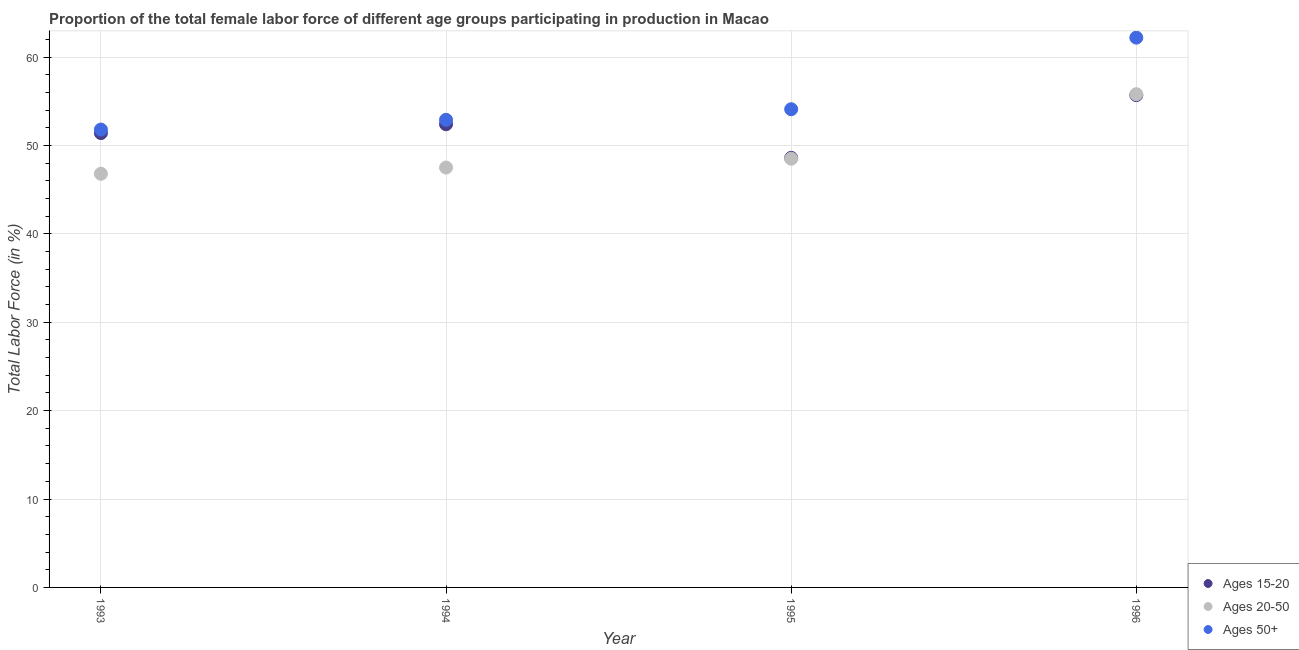How many different coloured dotlines are there?
Offer a very short reply. 3. Is the number of dotlines equal to the number of legend labels?
Offer a terse response. Yes. What is the percentage of female labor force above age 50 in 1993?
Provide a short and direct response. 51.8. Across all years, what is the maximum percentage of female labor force within the age group 20-50?
Keep it short and to the point. 55.8. Across all years, what is the minimum percentage of female labor force within the age group 20-50?
Make the answer very short. 46.8. In which year was the percentage of female labor force above age 50 minimum?
Offer a very short reply. 1993. What is the total percentage of female labor force above age 50 in the graph?
Ensure brevity in your answer.  221. What is the difference between the percentage of female labor force within the age group 15-20 in 1995 and that in 1996?
Make the answer very short. -7.1. What is the difference between the percentage of female labor force within the age group 20-50 in 1994 and the percentage of female labor force within the age group 15-20 in 1996?
Your response must be concise. -8.2. What is the average percentage of female labor force within the age group 20-50 per year?
Give a very brief answer. 49.65. In the year 1993, what is the difference between the percentage of female labor force above age 50 and percentage of female labor force within the age group 15-20?
Make the answer very short. 0.4. What is the ratio of the percentage of female labor force above age 50 in 1993 to that in 1996?
Ensure brevity in your answer.  0.83. Is the difference between the percentage of female labor force within the age group 15-20 in 1994 and 1996 greater than the difference between the percentage of female labor force within the age group 20-50 in 1994 and 1996?
Keep it short and to the point. Yes. What is the difference between the highest and the second highest percentage of female labor force within the age group 20-50?
Offer a very short reply. 7.3. What is the difference between the highest and the lowest percentage of female labor force above age 50?
Offer a terse response. 10.4. In how many years, is the percentage of female labor force within the age group 15-20 greater than the average percentage of female labor force within the age group 15-20 taken over all years?
Provide a succinct answer. 2. Is the sum of the percentage of female labor force within the age group 20-50 in 1994 and 1996 greater than the maximum percentage of female labor force above age 50 across all years?
Your answer should be very brief. Yes. Is the percentage of female labor force above age 50 strictly greater than the percentage of female labor force within the age group 15-20 over the years?
Provide a short and direct response. Yes. How many years are there in the graph?
Your answer should be compact. 4. Where does the legend appear in the graph?
Your response must be concise. Bottom right. What is the title of the graph?
Your answer should be compact. Proportion of the total female labor force of different age groups participating in production in Macao. What is the label or title of the Y-axis?
Provide a succinct answer. Total Labor Force (in %). What is the Total Labor Force (in %) in Ages 15-20 in 1993?
Your answer should be very brief. 51.4. What is the Total Labor Force (in %) of Ages 20-50 in 1993?
Offer a terse response. 46.8. What is the Total Labor Force (in %) in Ages 50+ in 1993?
Provide a succinct answer. 51.8. What is the Total Labor Force (in %) of Ages 15-20 in 1994?
Ensure brevity in your answer.  52.4. What is the Total Labor Force (in %) in Ages 20-50 in 1994?
Make the answer very short. 47.5. What is the Total Labor Force (in %) in Ages 50+ in 1994?
Your answer should be compact. 52.9. What is the Total Labor Force (in %) in Ages 15-20 in 1995?
Offer a terse response. 48.6. What is the Total Labor Force (in %) in Ages 20-50 in 1995?
Your answer should be compact. 48.5. What is the Total Labor Force (in %) in Ages 50+ in 1995?
Provide a succinct answer. 54.1. What is the Total Labor Force (in %) of Ages 15-20 in 1996?
Your response must be concise. 55.7. What is the Total Labor Force (in %) of Ages 20-50 in 1996?
Ensure brevity in your answer.  55.8. What is the Total Labor Force (in %) in Ages 50+ in 1996?
Offer a terse response. 62.2. Across all years, what is the maximum Total Labor Force (in %) in Ages 15-20?
Your response must be concise. 55.7. Across all years, what is the maximum Total Labor Force (in %) in Ages 20-50?
Your answer should be compact. 55.8. Across all years, what is the maximum Total Labor Force (in %) of Ages 50+?
Make the answer very short. 62.2. Across all years, what is the minimum Total Labor Force (in %) in Ages 15-20?
Make the answer very short. 48.6. Across all years, what is the minimum Total Labor Force (in %) in Ages 20-50?
Your answer should be very brief. 46.8. Across all years, what is the minimum Total Labor Force (in %) of Ages 50+?
Your response must be concise. 51.8. What is the total Total Labor Force (in %) of Ages 15-20 in the graph?
Make the answer very short. 208.1. What is the total Total Labor Force (in %) in Ages 20-50 in the graph?
Keep it short and to the point. 198.6. What is the total Total Labor Force (in %) in Ages 50+ in the graph?
Your response must be concise. 221. What is the difference between the Total Labor Force (in %) of Ages 50+ in 1993 and that in 1995?
Provide a short and direct response. -2.3. What is the difference between the Total Labor Force (in %) in Ages 15-20 in 1993 and that in 1996?
Give a very brief answer. -4.3. What is the difference between the Total Labor Force (in %) of Ages 20-50 in 1993 and that in 1996?
Provide a short and direct response. -9. What is the difference between the Total Labor Force (in %) in Ages 50+ in 1993 and that in 1996?
Offer a very short reply. -10.4. What is the difference between the Total Labor Force (in %) of Ages 20-50 in 1994 and that in 1995?
Provide a short and direct response. -1. What is the difference between the Total Labor Force (in %) in Ages 50+ in 1994 and that in 1995?
Give a very brief answer. -1.2. What is the difference between the Total Labor Force (in %) of Ages 15-20 in 1994 and that in 1996?
Make the answer very short. -3.3. What is the difference between the Total Labor Force (in %) of Ages 20-50 in 1995 and that in 1996?
Offer a very short reply. -7.3. What is the difference between the Total Labor Force (in %) in Ages 20-50 in 1993 and the Total Labor Force (in %) in Ages 50+ in 1994?
Make the answer very short. -6.1. What is the difference between the Total Labor Force (in %) of Ages 15-20 in 1993 and the Total Labor Force (in %) of Ages 50+ in 1995?
Provide a short and direct response. -2.7. What is the difference between the Total Labor Force (in %) of Ages 15-20 in 1993 and the Total Labor Force (in %) of Ages 20-50 in 1996?
Provide a short and direct response. -4.4. What is the difference between the Total Labor Force (in %) of Ages 15-20 in 1993 and the Total Labor Force (in %) of Ages 50+ in 1996?
Make the answer very short. -10.8. What is the difference between the Total Labor Force (in %) of Ages 20-50 in 1993 and the Total Labor Force (in %) of Ages 50+ in 1996?
Your answer should be very brief. -15.4. What is the difference between the Total Labor Force (in %) in Ages 15-20 in 1994 and the Total Labor Force (in %) in Ages 20-50 in 1996?
Offer a terse response. -3.4. What is the difference between the Total Labor Force (in %) of Ages 15-20 in 1994 and the Total Labor Force (in %) of Ages 50+ in 1996?
Your response must be concise. -9.8. What is the difference between the Total Labor Force (in %) of Ages 20-50 in 1994 and the Total Labor Force (in %) of Ages 50+ in 1996?
Make the answer very short. -14.7. What is the difference between the Total Labor Force (in %) of Ages 15-20 in 1995 and the Total Labor Force (in %) of Ages 20-50 in 1996?
Your response must be concise. -7.2. What is the difference between the Total Labor Force (in %) of Ages 15-20 in 1995 and the Total Labor Force (in %) of Ages 50+ in 1996?
Make the answer very short. -13.6. What is the difference between the Total Labor Force (in %) of Ages 20-50 in 1995 and the Total Labor Force (in %) of Ages 50+ in 1996?
Make the answer very short. -13.7. What is the average Total Labor Force (in %) of Ages 15-20 per year?
Offer a very short reply. 52.02. What is the average Total Labor Force (in %) in Ages 20-50 per year?
Offer a very short reply. 49.65. What is the average Total Labor Force (in %) of Ages 50+ per year?
Your answer should be compact. 55.25. In the year 1993, what is the difference between the Total Labor Force (in %) in Ages 15-20 and Total Labor Force (in %) in Ages 50+?
Your answer should be compact. -0.4. In the year 1993, what is the difference between the Total Labor Force (in %) of Ages 20-50 and Total Labor Force (in %) of Ages 50+?
Make the answer very short. -5. In the year 1994, what is the difference between the Total Labor Force (in %) in Ages 15-20 and Total Labor Force (in %) in Ages 20-50?
Provide a short and direct response. 4.9. In the year 1994, what is the difference between the Total Labor Force (in %) in Ages 15-20 and Total Labor Force (in %) in Ages 50+?
Make the answer very short. -0.5. In the year 1995, what is the difference between the Total Labor Force (in %) of Ages 15-20 and Total Labor Force (in %) of Ages 20-50?
Keep it short and to the point. 0.1. In the year 1995, what is the difference between the Total Labor Force (in %) in Ages 15-20 and Total Labor Force (in %) in Ages 50+?
Provide a succinct answer. -5.5. What is the ratio of the Total Labor Force (in %) in Ages 15-20 in 1993 to that in 1994?
Your answer should be compact. 0.98. What is the ratio of the Total Labor Force (in %) in Ages 50+ in 1993 to that in 1994?
Provide a succinct answer. 0.98. What is the ratio of the Total Labor Force (in %) in Ages 15-20 in 1993 to that in 1995?
Your answer should be compact. 1.06. What is the ratio of the Total Labor Force (in %) of Ages 20-50 in 1993 to that in 1995?
Ensure brevity in your answer.  0.96. What is the ratio of the Total Labor Force (in %) in Ages 50+ in 1993 to that in 1995?
Keep it short and to the point. 0.96. What is the ratio of the Total Labor Force (in %) of Ages 15-20 in 1993 to that in 1996?
Your response must be concise. 0.92. What is the ratio of the Total Labor Force (in %) of Ages 20-50 in 1993 to that in 1996?
Make the answer very short. 0.84. What is the ratio of the Total Labor Force (in %) of Ages 50+ in 1993 to that in 1996?
Offer a very short reply. 0.83. What is the ratio of the Total Labor Force (in %) of Ages 15-20 in 1994 to that in 1995?
Your answer should be very brief. 1.08. What is the ratio of the Total Labor Force (in %) in Ages 20-50 in 1994 to that in 1995?
Your response must be concise. 0.98. What is the ratio of the Total Labor Force (in %) in Ages 50+ in 1994 to that in 1995?
Provide a succinct answer. 0.98. What is the ratio of the Total Labor Force (in %) in Ages 15-20 in 1994 to that in 1996?
Your answer should be compact. 0.94. What is the ratio of the Total Labor Force (in %) in Ages 20-50 in 1994 to that in 1996?
Offer a terse response. 0.85. What is the ratio of the Total Labor Force (in %) in Ages 50+ in 1994 to that in 1996?
Make the answer very short. 0.85. What is the ratio of the Total Labor Force (in %) in Ages 15-20 in 1995 to that in 1996?
Give a very brief answer. 0.87. What is the ratio of the Total Labor Force (in %) in Ages 20-50 in 1995 to that in 1996?
Your answer should be very brief. 0.87. What is the ratio of the Total Labor Force (in %) in Ages 50+ in 1995 to that in 1996?
Offer a very short reply. 0.87. What is the difference between the highest and the second highest Total Labor Force (in %) of Ages 20-50?
Offer a very short reply. 7.3. What is the difference between the highest and the lowest Total Labor Force (in %) of Ages 15-20?
Offer a terse response. 7.1. 